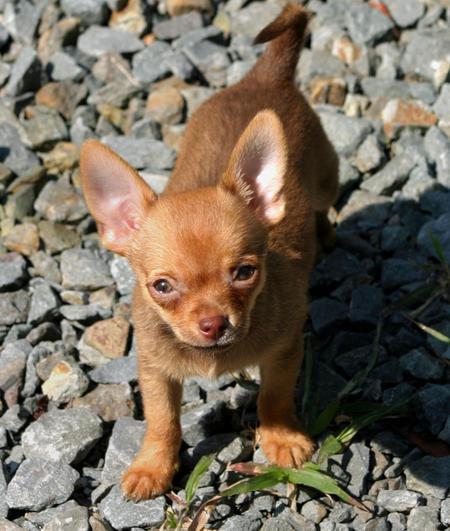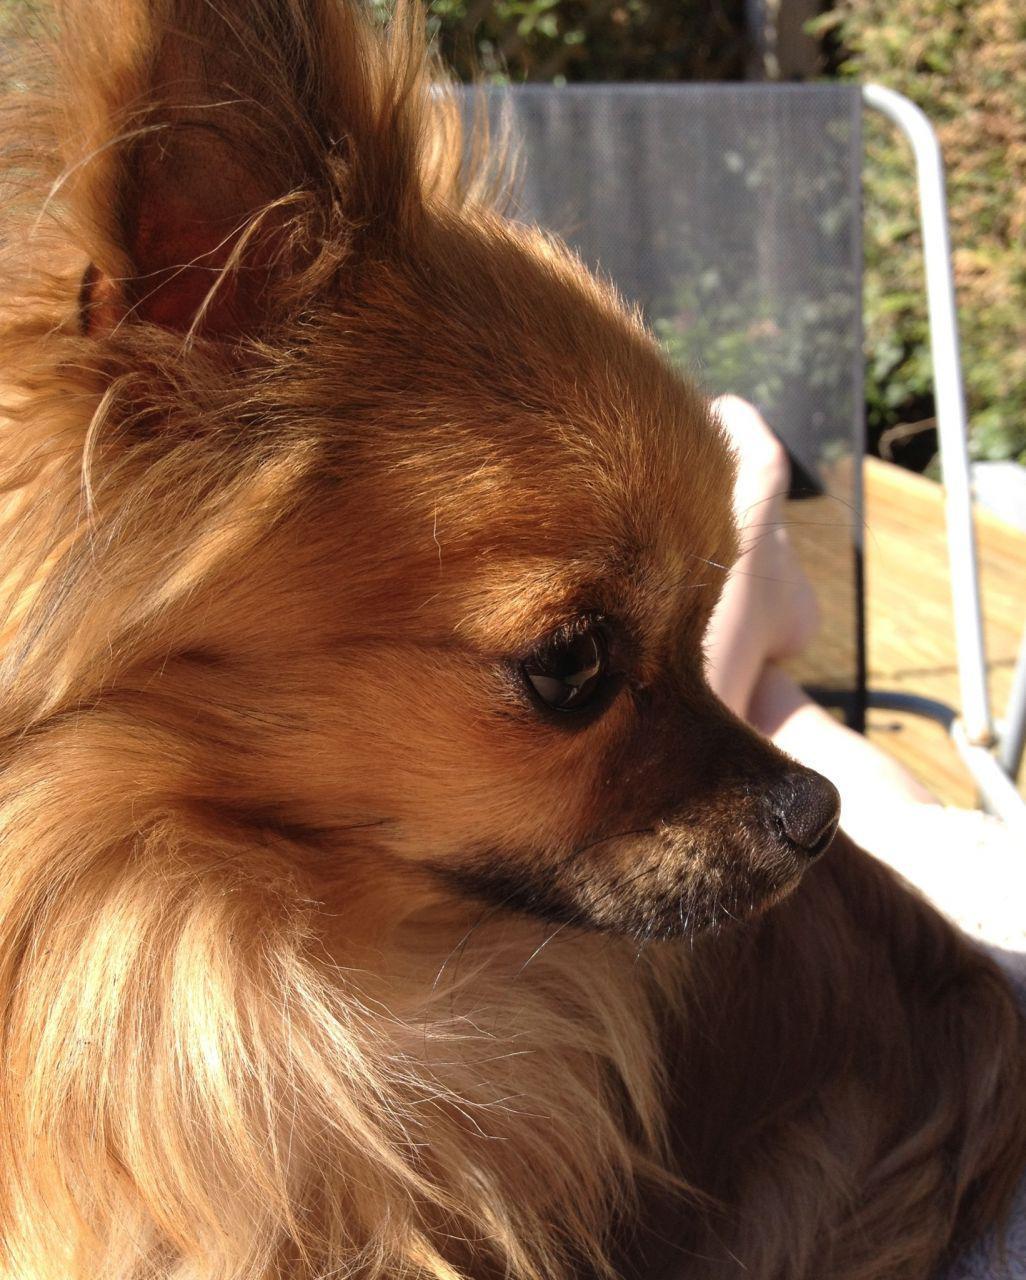The first image is the image on the left, the second image is the image on the right. Evaluate the accuracy of this statement regarding the images: "The dog in the image on the left is looking toward the camera.". Is it true? Answer yes or no. Yes. 